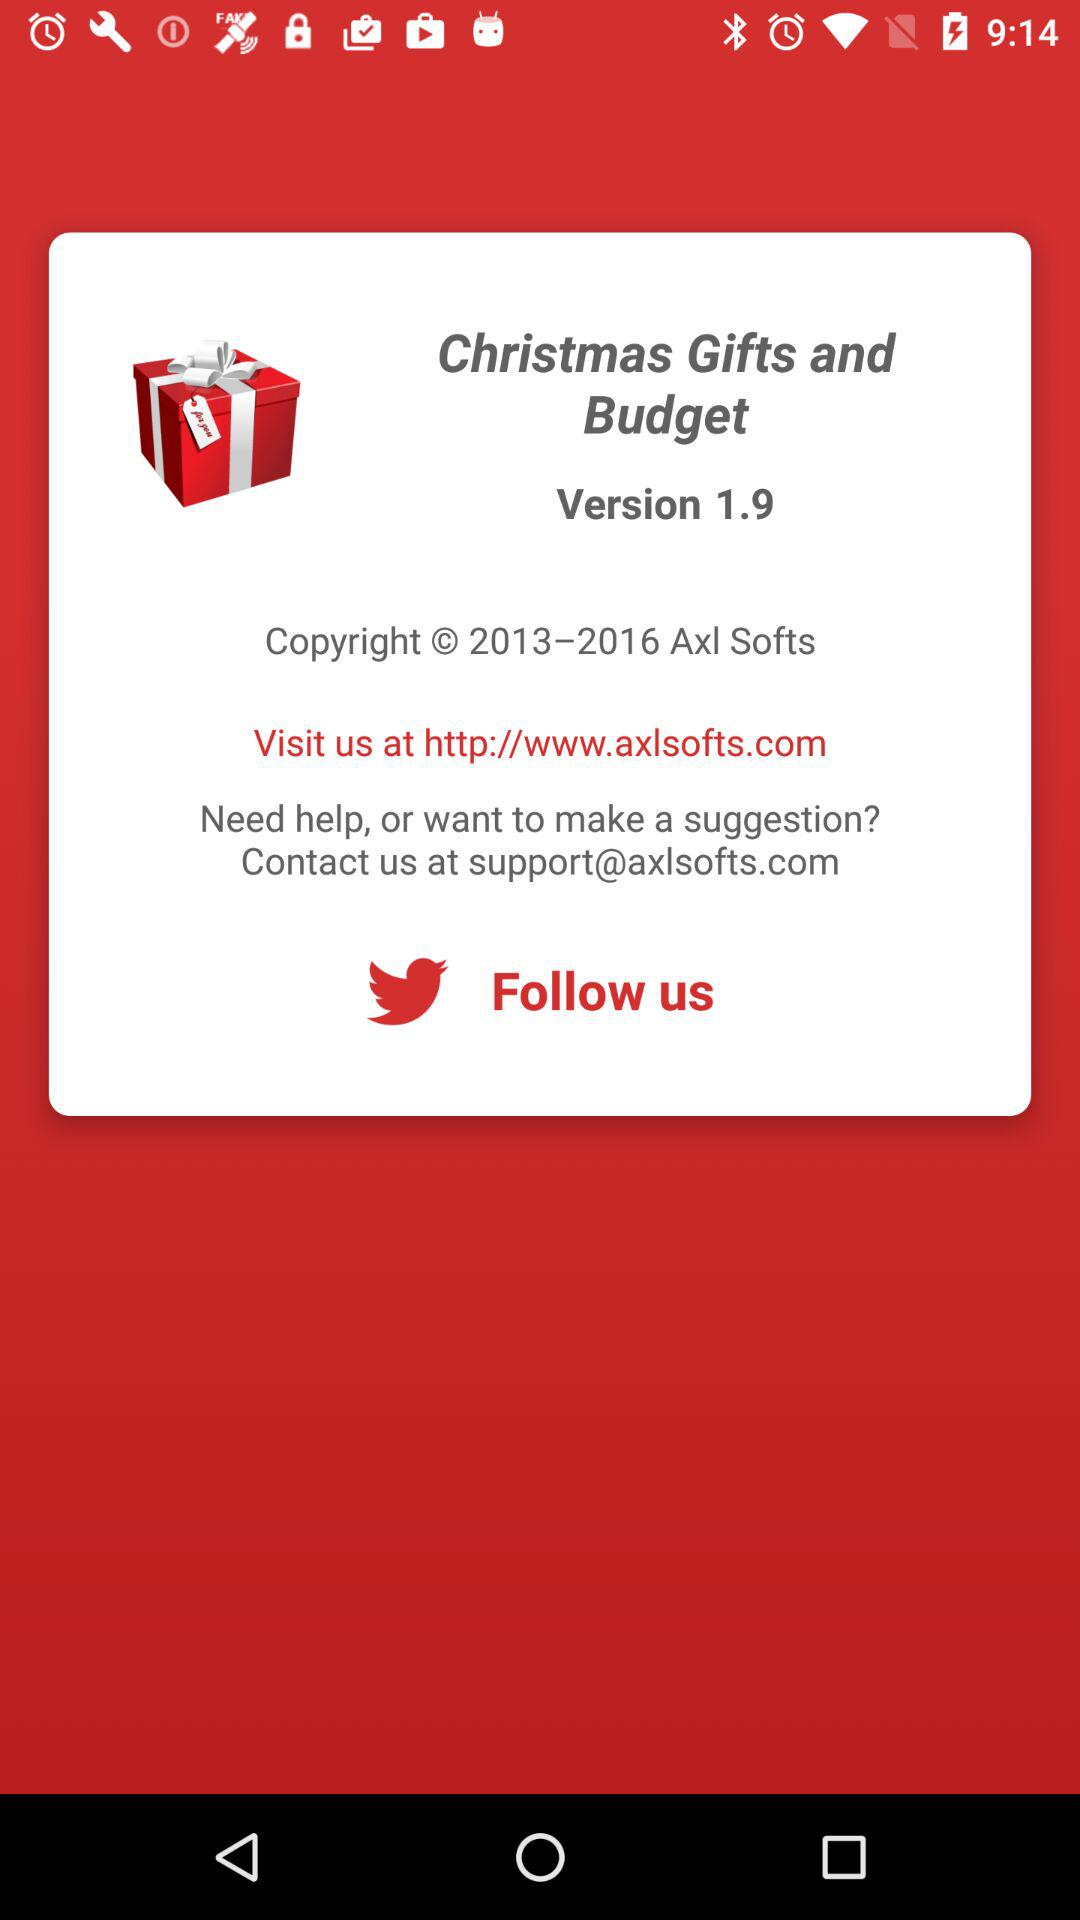What is the version of the application? The version of the application is 1.9. 